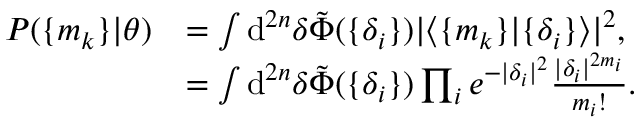<formula> <loc_0><loc_0><loc_500><loc_500>\begin{array} { r l } { P ( \{ m _ { k } \} | \theta ) } & { = \int d ^ { 2 n } { \delta } \tilde { \Phi } ( \{ \delta _ { i } \} ) | \langle \{ m _ { k } \} | \{ \delta _ { i } \} \rangle | ^ { 2 } , } \\ & { = \int d ^ { 2 n } { \delta } \tilde { \Phi } ( \{ \delta _ { i } \} ) \prod _ { i } e ^ { - | \delta _ { i } | ^ { 2 } } \frac { | \delta _ { i } | ^ { 2 m _ { i } } } { m _ { i } ! } . } \end{array}</formula> 